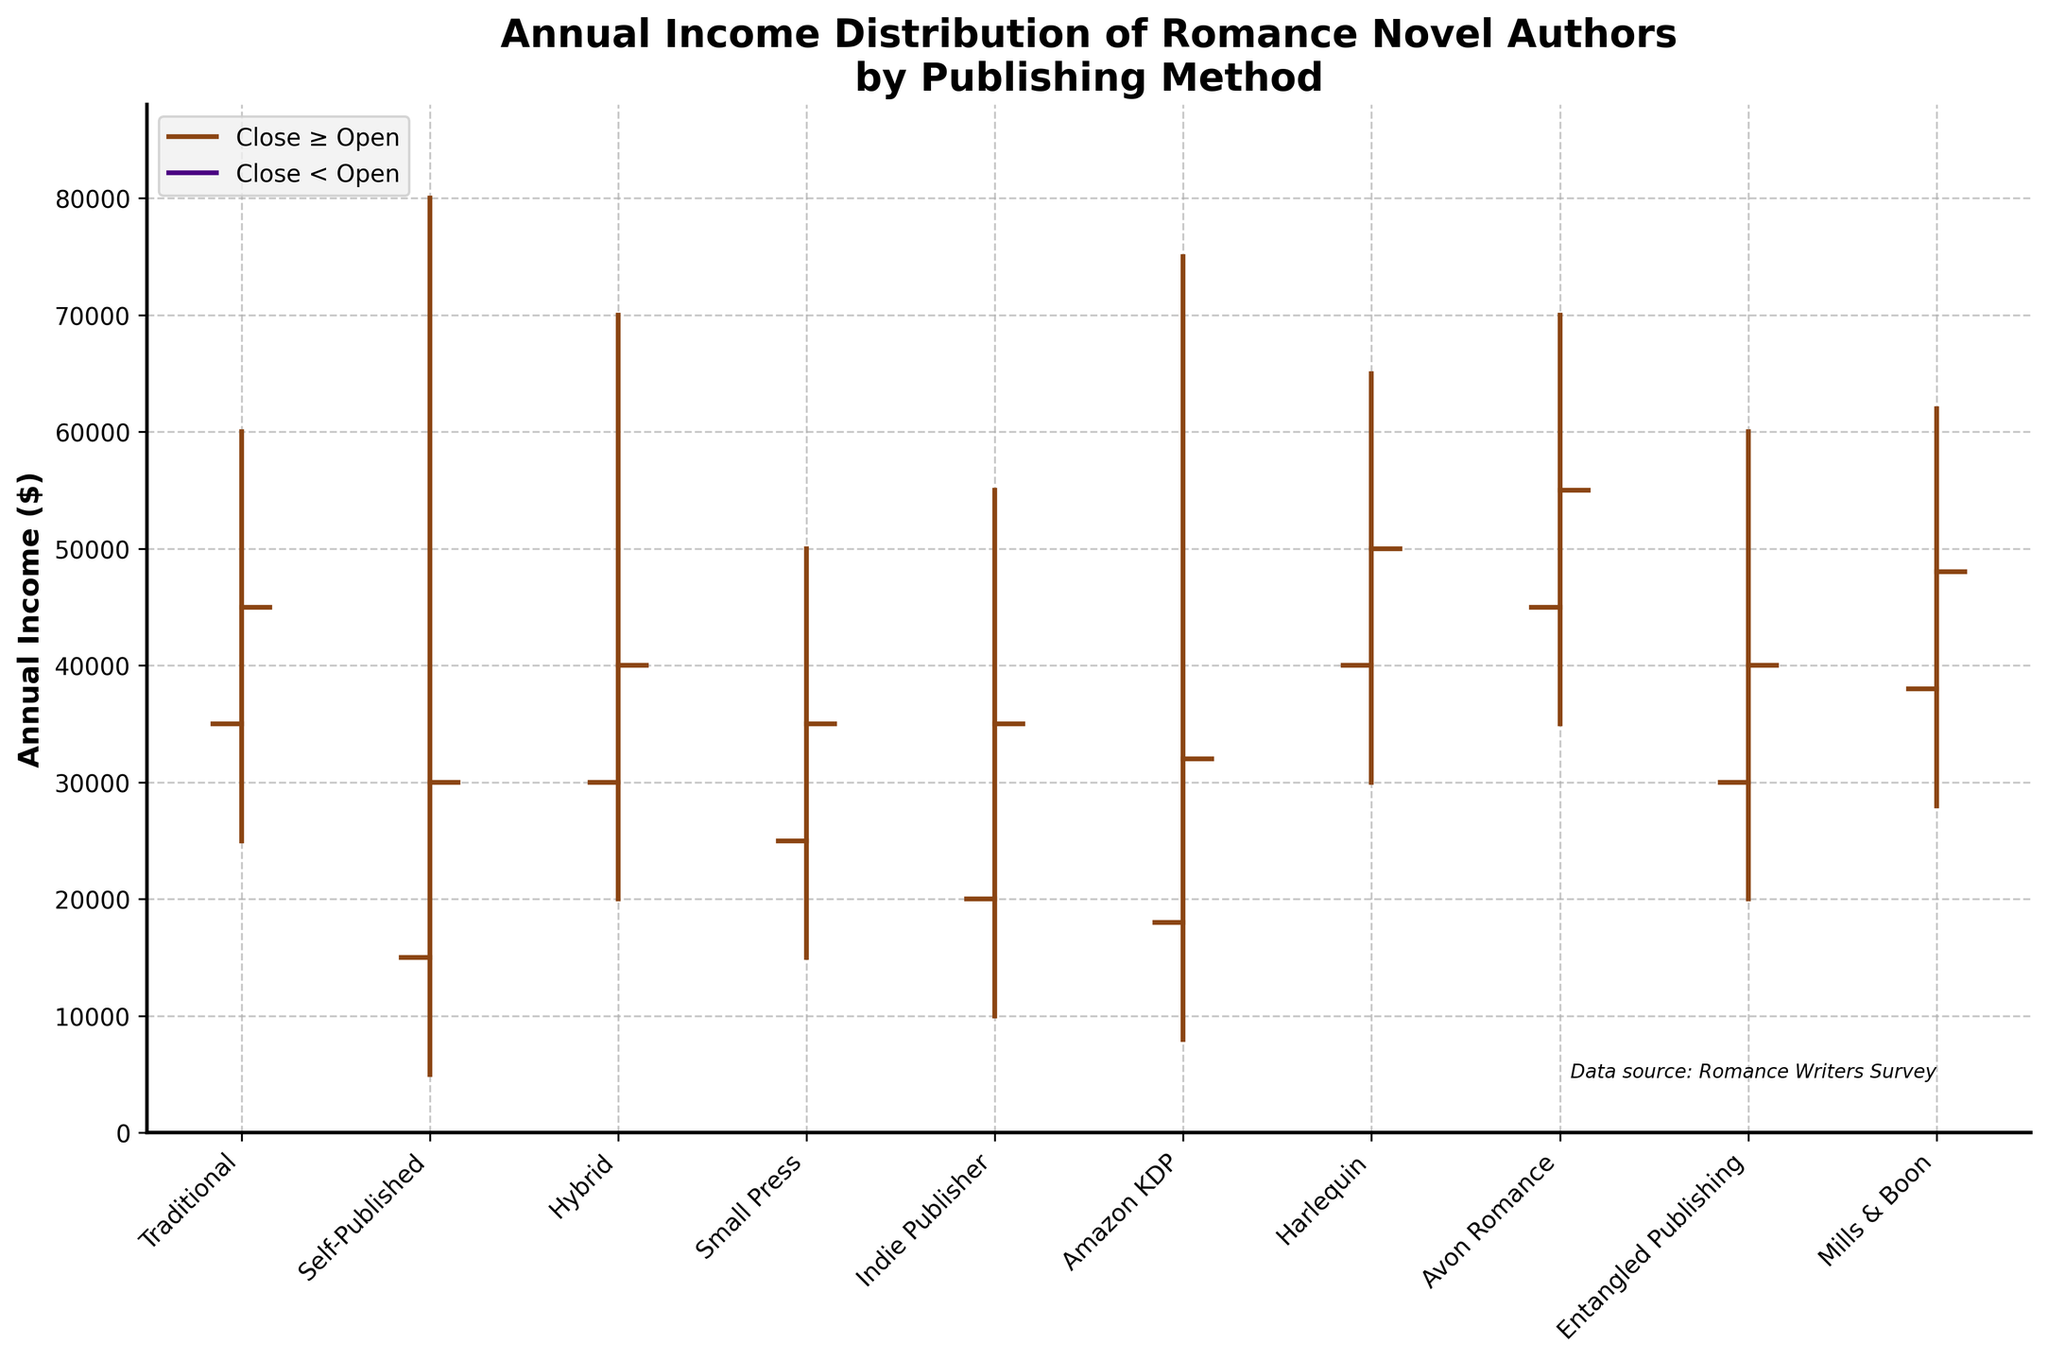Which publishing method has the highest high value? From the figure, the highest high value is represented by the longest vertical line or highest point reached, which corresponds to Self-Published with $80,000.
Answer: Self-Published What is the average low value of the publishing methods? Add all the low values together and divide by the number of methods: (25000 + 5000 + 20000 + 15000 + 10000 + 8000 + 30000 + 35000 + 20000 + 28000)/10 = 20100.
Answer: $20,100 Between which two publishing methods is the income spread (difference between high and low values) the greatest? Calculate the spread for each method, then compare: 
- Traditional: 60000 - 25000 = 35000 
- Self-Published: 80000 - 5000 = 75000 
- Hybrid: 70000 - 20000 = 50000 
- Small Press: 50000 - 15000 = 35000 
- Indie Publisher: 55000 - 10000 = 45000 
- Amazon KDP: 75000 - 8000 = 67000 
- Harlequin: 65000 - 30000 = 35000 
- Avon Romance: 70000 - 35000 = 35000 
- Entangled Publishing: 60000 - 20000 = 40000 
- Mills & Boon: 62000 - 28000 = 34000 
Self-Published has the largest spread with $75,000.
Answer: Self-Published Which publishing method shows the smallest range between their open and close values? Calculate the range (absolute difference) between open and close values and find the smallest:
- Traditional: abs(45000 - 35000) = 10000 
- Self-Published: abs(30000 - 15000) = 15000 
- Hybrid: abs(40000 - 30000) = 10000 
- Small Press: abs(35000 - 25000) = 10000 
- Indie Publisher: abs(35000 - 20000) = 15000 
- Amazon KDP: abs(32000 - 18000) = 14000 
- Harlequin: abs(50000 - 40000) = 10000 
- Avon Romance: abs(55000 - 45000) = 10000 
- Entangled Publishing: abs(40000 - 30000) = 10000 
- Mills & Boon: abs(48000 - 38000) = 10000
All have the same smallest range of $10,000.
Answer: Traditional, Hybrid, Small Press, Harlequin, Avon Romance, Entangled Publishing, Mills & Boon Which publishing method has the highest open value? The highest open value is represented by the highest open tick in the figure, and it corresponds to Avon Romance with $45,000.
Answer: Avon Romance What is the median close value of all publishing methods? Sort the close values: [30000, 30000, 35000, 35000, 35000, 40000, 40000, 45000, 48000, 50000]. The median, being the average of the 5th and 6th values (the middle two in the sorted list), is (35000 + 40000)/2 = 37500.
Answer: $37,500 Which publishing method demonstrates the most significant income increase from open to close? Calculate the income increase for each method and find the largest positive difference:
- Traditional: 45000 - 35000 = 10000 
- Self-Published: 30000 - 15000 = 15000 
- Hybrid: 40000 - 30000 = 10000 
- Small Press: 35000 - 25000 = 10000 
- Indie Publisher: 35000 - 20000 = 15000 
- Amazon KDP: 32000 - 18000 = 14000 
- Harlequin: 50000 - 40000 = 10000 
- Avon Romance: 55000 - 45000 = 10000 
- Entangled Publishing: 40000 - 30000 = 10000 
- Mills & Boon: 48000 - 38000 = 10000
Self-Published and Indie Publisher both show the largest increase of $15,000.
Answer: Self-Published, Indie Publisher 